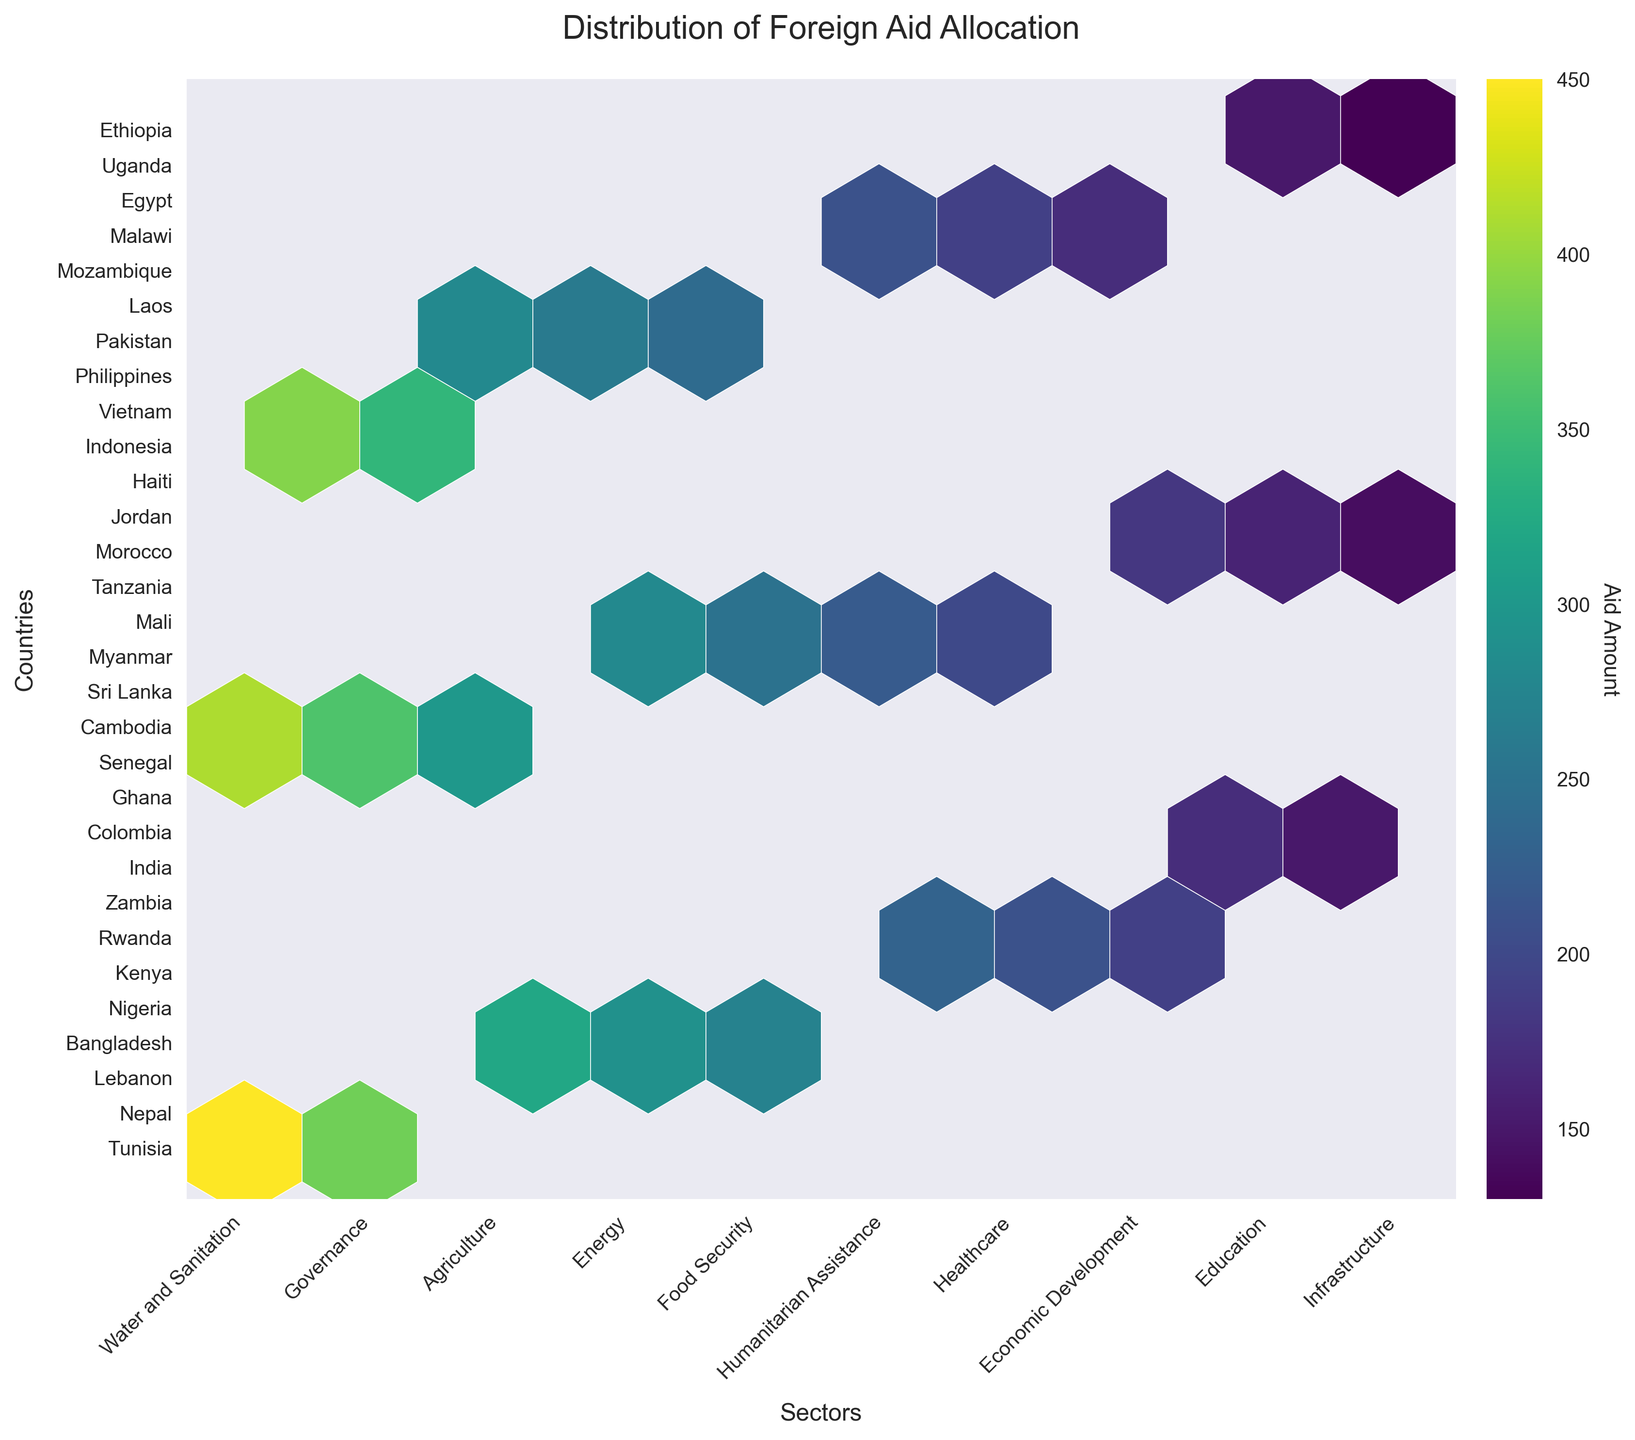what is the title of the figure? The title can be found at the top of the figure. In this case, it reads "Distribution of Foreign Aid Allocation".
Answer: Distribution of Foreign Aid Allocation how are the sectors labeled on the x-axis? The sectors are represented as labels on the x-axis. They should be written in natural language, based on the unique sectors in the data. These include Education, Healthcare, Agriculture, Water and Sanitation, Economic Development, Humanitarian Assistance, Governance, Energy, Food Security, and Infrastructure.
Answer: Education, Healthcare, Agriculture, Water and Sanitation, Economic Development, Humanitarian Assistance, Governance, Energy, Food Security, Infrastructure how is the color used in the hexbin plot? The color intensity in the hexbin plot represents the aid amount, with darker colors indicating higher aid amounts. This can be understood by looking at the colorbar, which maps color intensity to aid values.
Answer: Darker colors indicate higher aid amounts which country receives the most aid for the healthcare sector? To determine this, locate the healthcare sector on the x-axis. Then, identify the country corresponding to the darkest hexbin in this column by referring to the y-axis labels.
Answer: Nigeria how many sectors does Kenya receive aid for? Identify the `Kenya` label on the y-axis, then count the number of hexbins in that row, each representing a different sector that receives aid.
Answer: 1 which sector and country combination receives the highest aid amount? Look for the darkest hexbin on the entire plot. Then, refer to the x-axis for the sector and y-axis for the country.
Answer: Education, India which country receives more aid overall, India or Nigeria? Compare the aid amounts represented by the color intensity of hexbins related to India and Nigeria across all sectors. India has at least one very dark hexbin, suggesting higher aid in the education sector alone, making it likely that India receives more aid overall.
Answer: India what is the median aid amount across all sectors and countries? Observe the color bar and interpret the middle range color that corresponds to the median value. Calculating the actual values would require numerical summation and division but visually, the median falls in the middle color range.
Answer: Approx. between 190 and 250 which sectors have the most countries receiving aid? Count the number of different countries (y-axis labels) for each sector (x-axis labels). Sectors like Education, Healthcare, Agriculture, and perhaps Water and Sanitation have multiple dark and light hexbins, indicating more countries receiving aid.
Answer: Education, Healthcare, Agriculture, Water and Sanitation in terms of aid distribution patterns, which country receives aid across the most diverse sectors? Identify the country with hexbins in the most number of different sectors. This can be done by locating the country on the y-axis and counting the number of filled hexbins across the x-axis.
Answer: Sri Lanka 